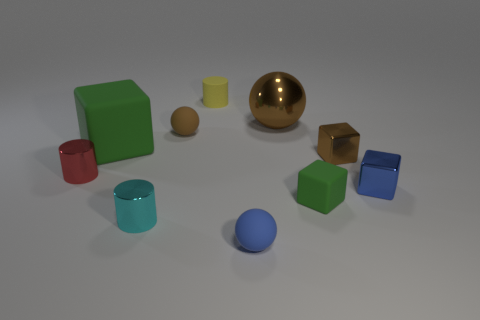What color is the big metal thing to the left of the tiny brown metal cube?
Offer a terse response. Brown. Are there any brown balls that are on the right side of the big thing to the right of the tiny cylinder behind the large brown ball?
Your answer should be very brief. No. Are there more brown rubber objects right of the small green matte thing than blue rubber spheres?
Offer a very short reply. No. There is a tiny cyan metallic object that is to the left of the blue block; is its shape the same as the tiny yellow matte object?
Your answer should be very brief. Yes. What number of objects are tiny blue cubes or brown things that are to the left of the tiny yellow cylinder?
Ensure brevity in your answer.  2. There is a object that is both behind the big green rubber block and left of the yellow thing; what size is it?
Provide a succinct answer. Small. Are there more blue rubber balls in front of the tiny cyan object than tiny blue balls that are behind the tiny rubber cylinder?
Your answer should be very brief. Yes. There is a blue metallic thing; is its shape the same as the brown metallic object that is behind the tiny brown sphere?
Your answer should be compact. No. What number of other things are there of the same shape as the small blue rubber thing?
Make the answer very short. 2. What color is the metallic thing that is left of the tiny blue matte ball and behind the tiny cyan metal object?
Give a very brief answer. Red. 